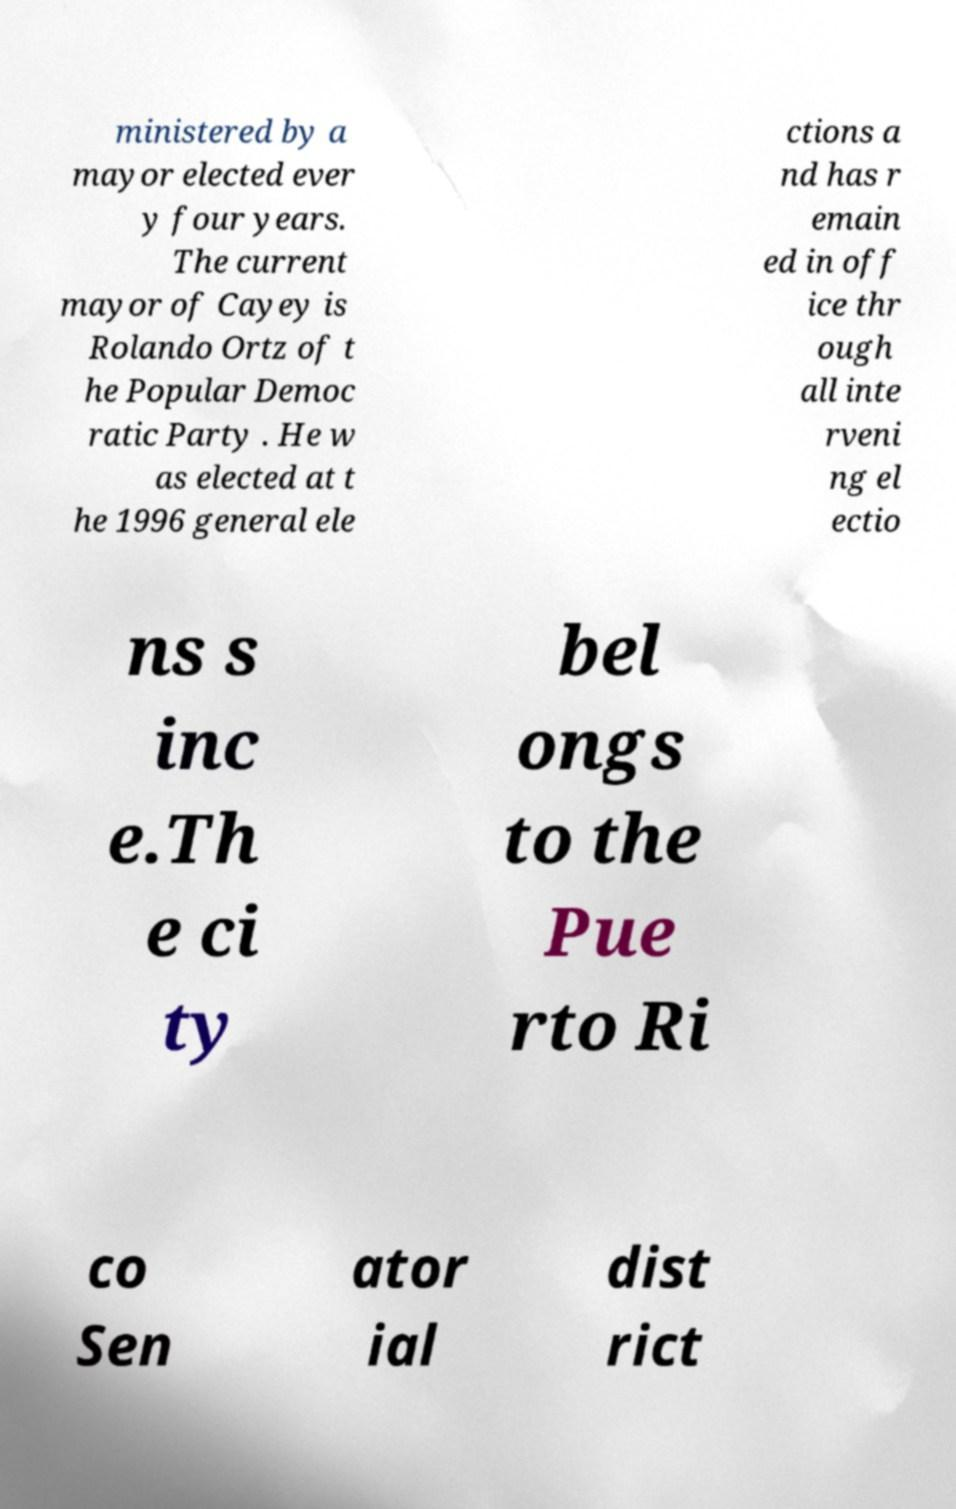Can you accurately transcribe the text from the provided image for me? ministered by a mayor elected ever y four years. The current mayor of Cayey is Rolando Ortz of t he Popular Democ ratic Party . He w as elected at t he 1996 general ele ctions a nd has r emain ed in off ice thr ough all inte rveni ng el ectio ns s inc e.Th e ci ty bel ongs to the Pue rto Ri co Sen ator ial dist rict 